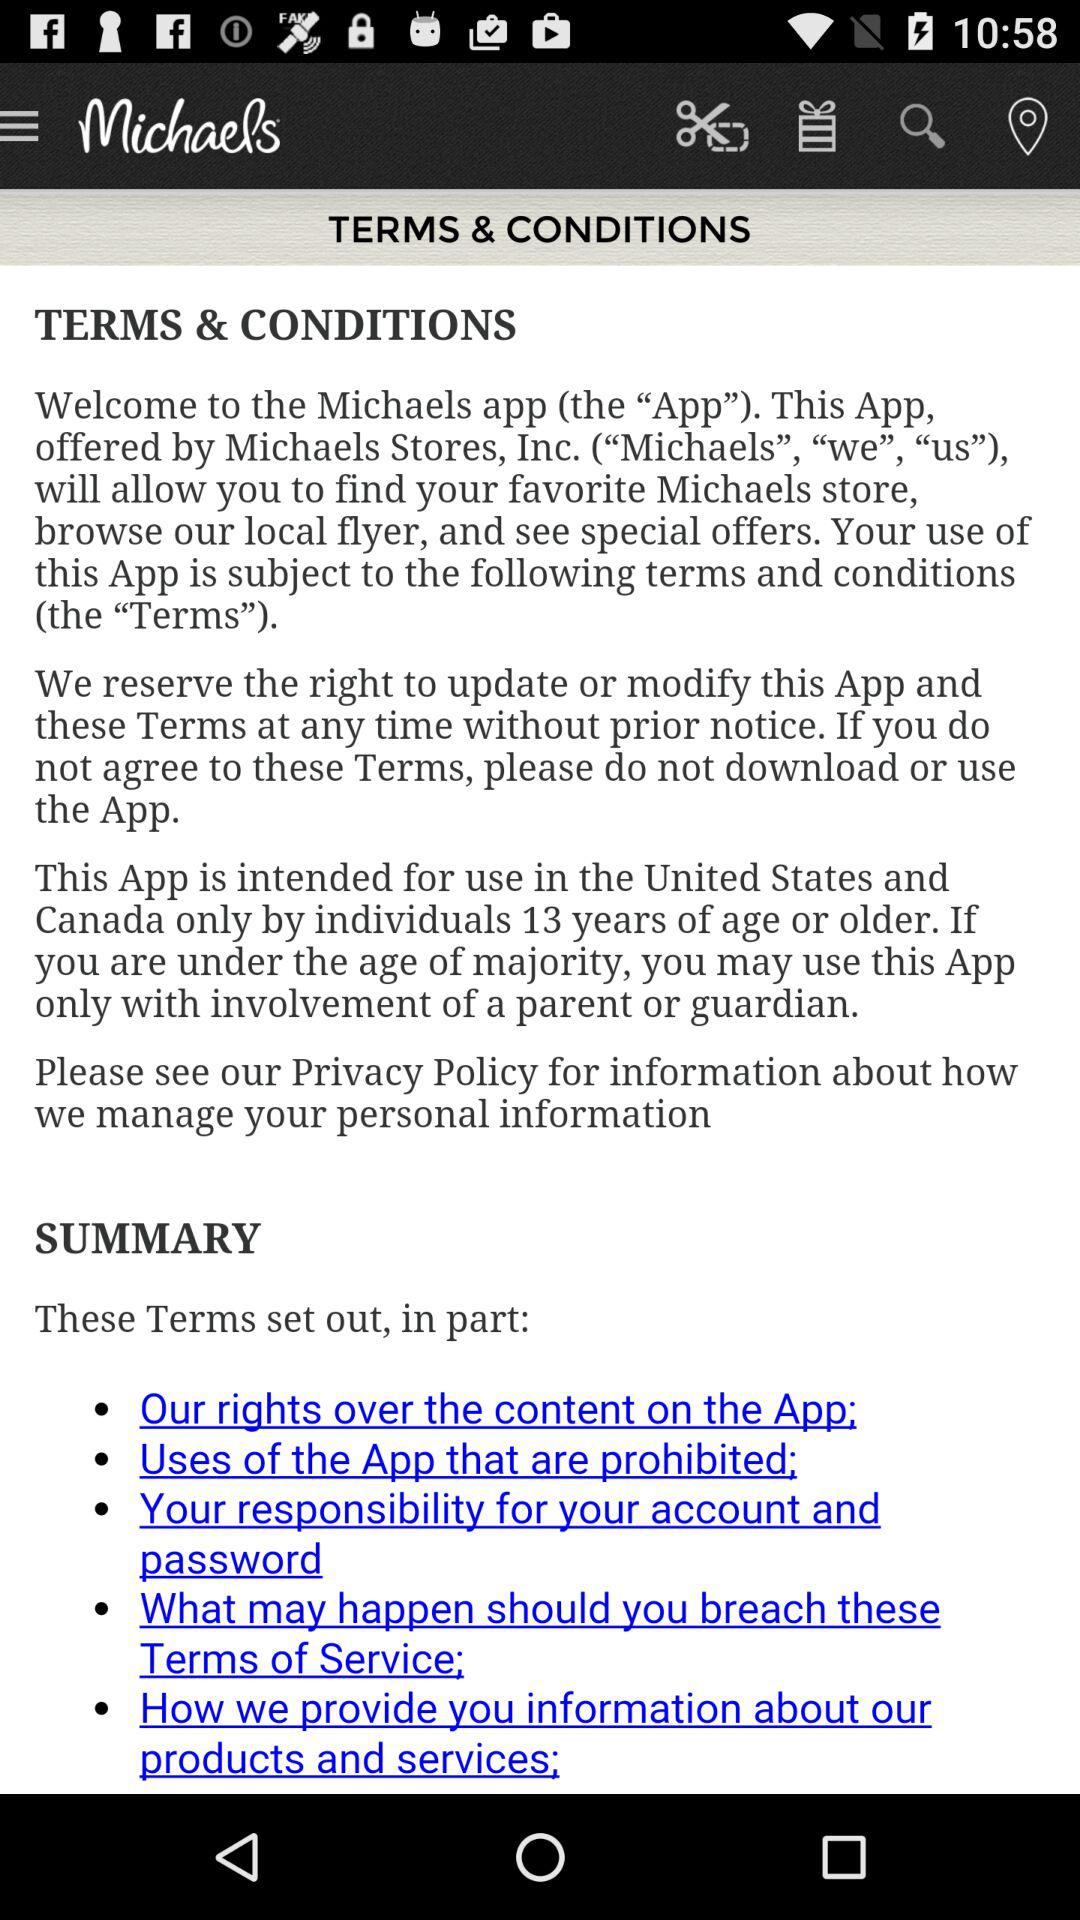What is the application name? The application name is "Michaels". 